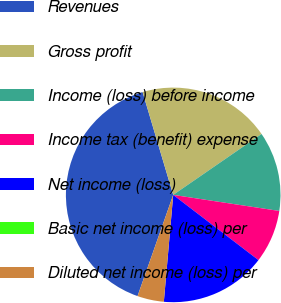Convert chart. <chart><loc_0><loc_0><loc_500><loc_500><pie_chart><fcel>Revenues<fcel>Gross profit<fcel>Income (loss) before income<fcel>Income tax (benefit) expense<fcel>Net income (loss)<fcel>Basic net income (loss) per<fcel>Diluted net income (loss) per<nl><fcel>40.0%<fcel>20.0%<fcel>12.0%<fcel>8.0%<fcel>16.0%<fcel>0.0%<fcel>4.0%<nl></chart> 